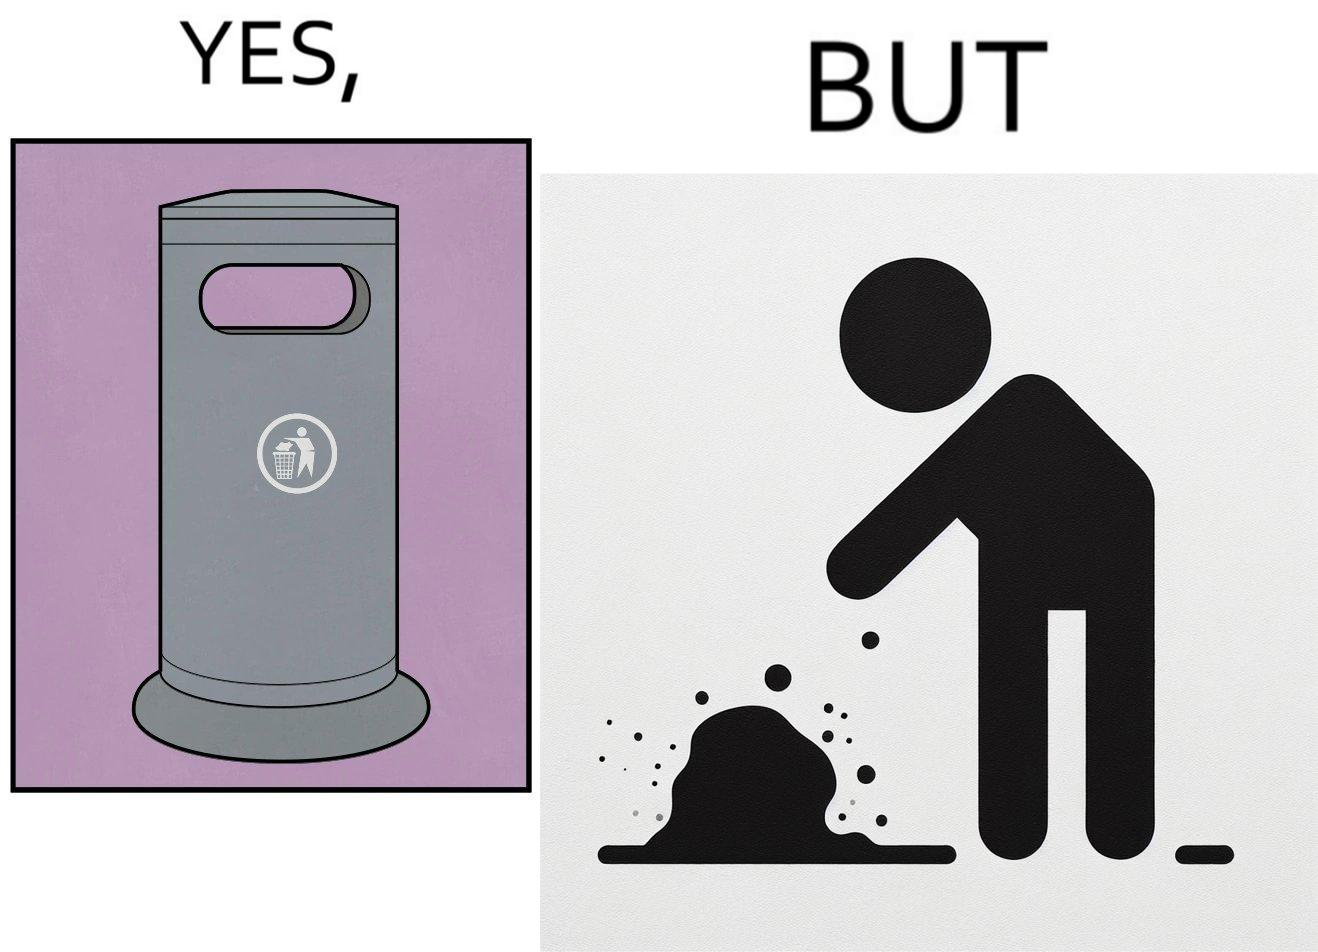Is there satirical content in this image? Yes, this image is satirical. 